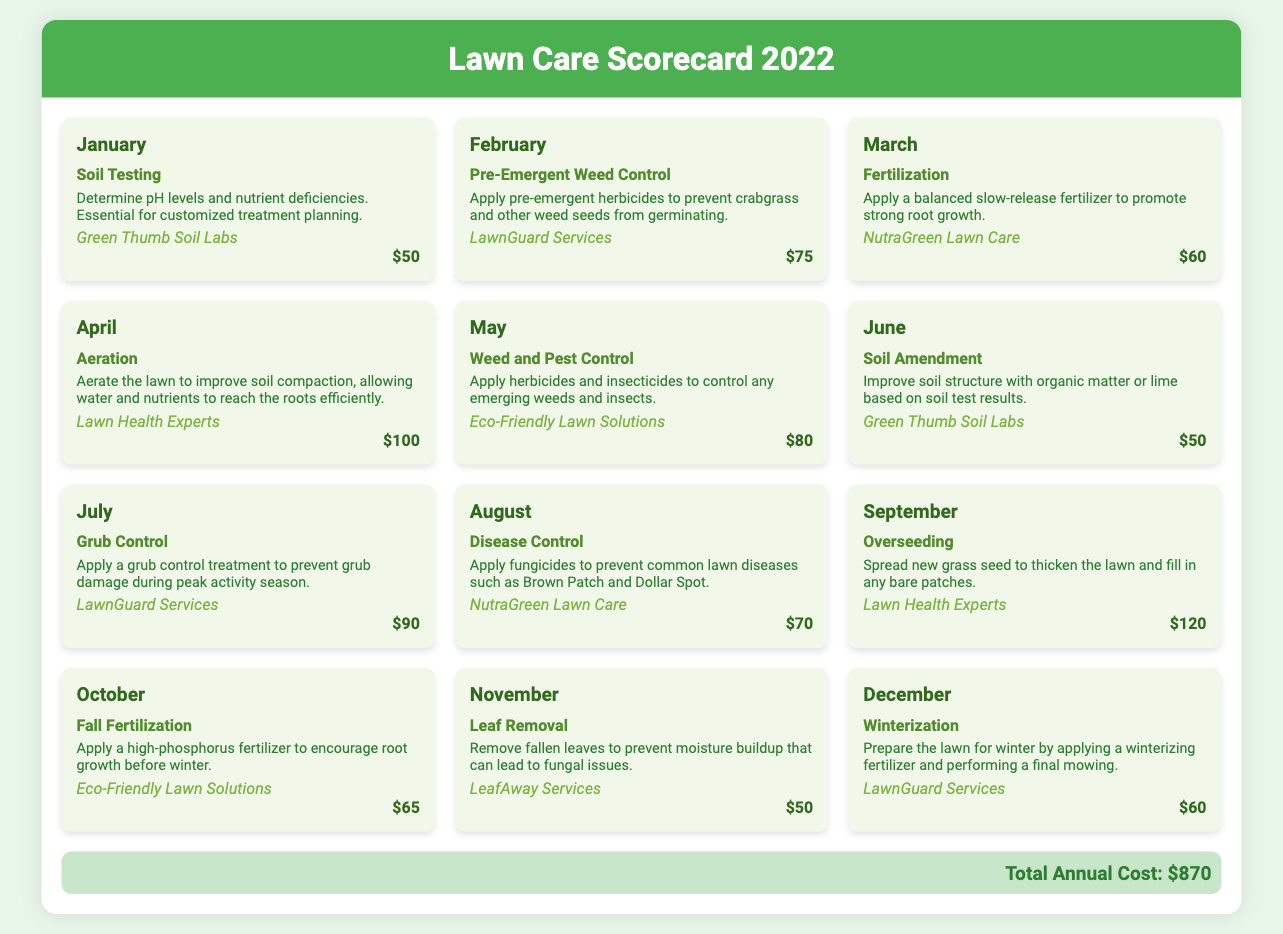What service is provided in January? The service provided in January is Soil Testing, as listed in the scorecard.
Answer: Soil Testing Who is the provider for Overseeding? The provider for Overseeding is found under the September month card in the scorecard.
Answer: Lawn Health Experts What is the total cost for the lawn treatment services? The total cost is mentioned at the bottom of the scorecard, which includes all monthly services throughout the year.
Answer: $870 How much does the Aeration service cost? The cost of the Aeration service is provided in the April month card of the scorecard.
Answer: $100 Which month includes Leaf Removal service? The month that includes Leaf Removal is identified by looking at the specific month card in the scorecard.
Answer: November Which service is provided in July? The service listed for July in the scorecard needs to be checked.
Answer: Grub Control What is the cost of Winterization service? The cost is specified in the December month card detailing the Winterization service.
Answer: $60 What is the description of the Fertilization service? The description can be found in the March month card of the scorecard that outlines the service specifics.
Answer: Apply a balanced slow-release fertilizer to promote strong root growth Who provides the Disease Control service? The provider's name is mentioned in the August month card providing the Disease Control service.
Answer: NutraGreen Lawn Care 